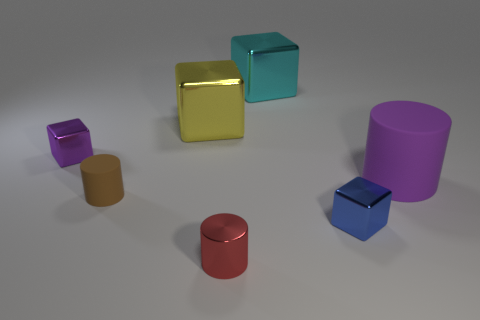Subtract 1 cubes. How many cubes are left? 3 Add 1 small red metal cylinders. How many objects exist? 8 Subtract all cubes. How many objects are left? 3 Subtract 1 yellow cubes. How many objects are left? 6 Subtract all big brown metallic cylinders. Subtract all big shiny cubes. How many objects are left? 5 Add 7 big purple rubber cylinders. How many big purple rubber cylinders are left? 8 Add 3 tiny red cylinders. How many tiny red cylinders exist? 4 